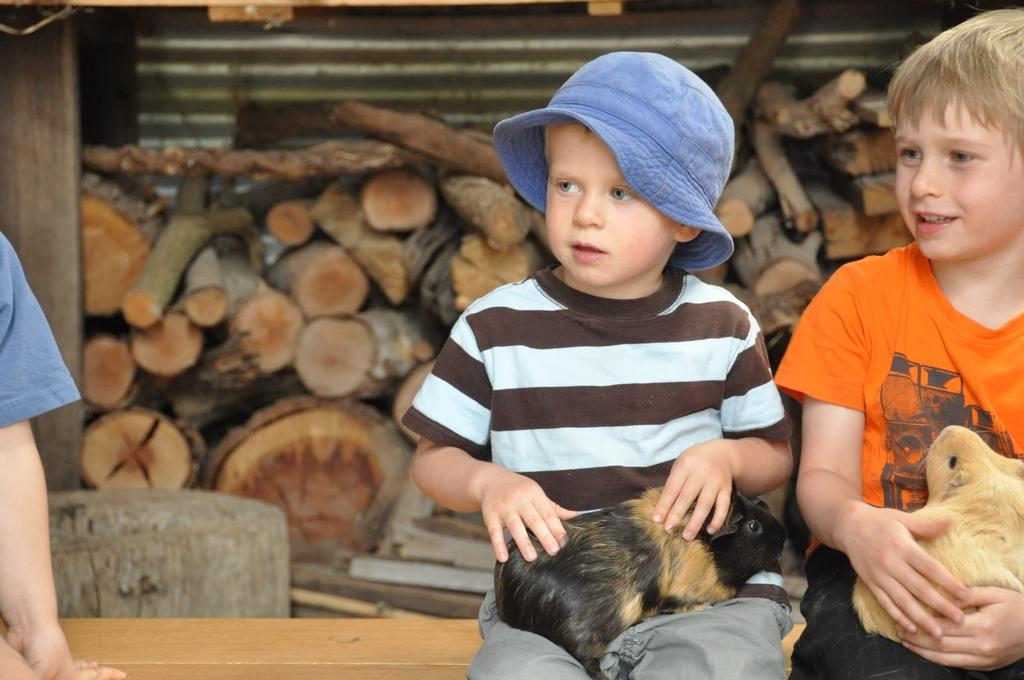What is the main object in the image? There is a table in the image. What are the boys doing while sitting on the table? The boys are holding rabbits on their laps. What can be seen under the shed in the image? There are chopped wooden pieces under a shed. What type of worm can be seen crawling on the table in the image? There is no worm present in the image; the boys are holding rabbits on their laps. 